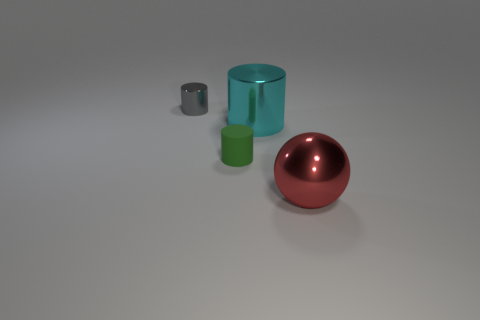What color is the matte thing?
Your response must be concise. Green. There is a large metal thing in front of the large thing to the left of the large red metal thing; what color is it?
Offer a very short reply. Red. There is a tiny cylinder behind the tiny cylinder that is in front of the large cyan shiny cylinder; how many objects are on the right side of it?
Ensure brevity in your answer.  3. Are there any gray shiny cylinders to the right of the green cylinder?
Your response must be concise. No. Are there any other things that are the same color as the small rubber object?
Offer a very short reply. No. How many cylinders are either big yellow metal things or red metallic things?
Your answer should be compact. 0. What number of tiny objects are both behind the large cyan cylinder and in front of the large cyan object?
Provide a succinct answer. 0. Is the number of large metallic objects on the right side of the tiny gray metal cylinder the same as the number of tiny objects that are behind the big red ball?
Keep it short and to the point. Yes. There is a tiny thing that is in front of the tiny shiny cylinder; is it the same shape as the cyan object?
Give a very brief answer. Yes. There is a small object that is in front of the shiny cylinder in front of the tiny object left of the small matte object; what shape is it?
Offer a terse response. Cylinder. 